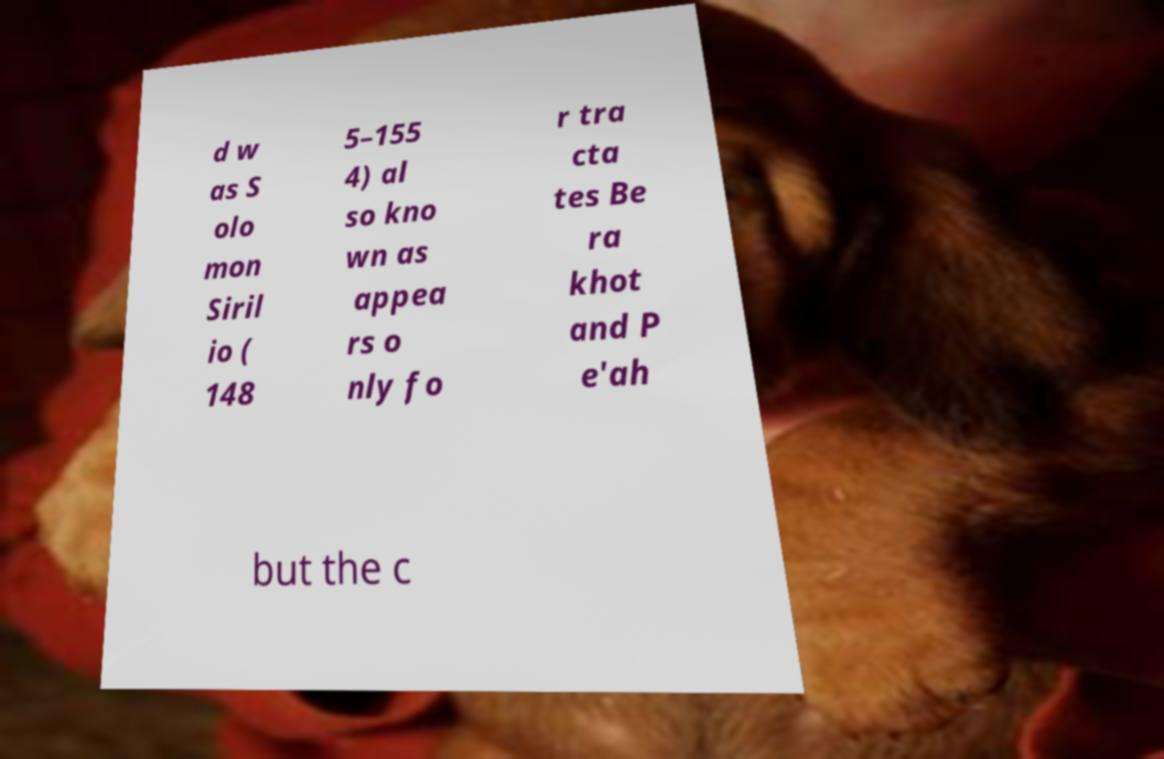There's text embedded in this image that I need extracted. Can you transcribe it verbatim? d w as S olo mon Siril io ( 148 5–155 4) al so kno wn as appea rs o nly fo r tra cta tes Be ra khot and P e'ah but the c 